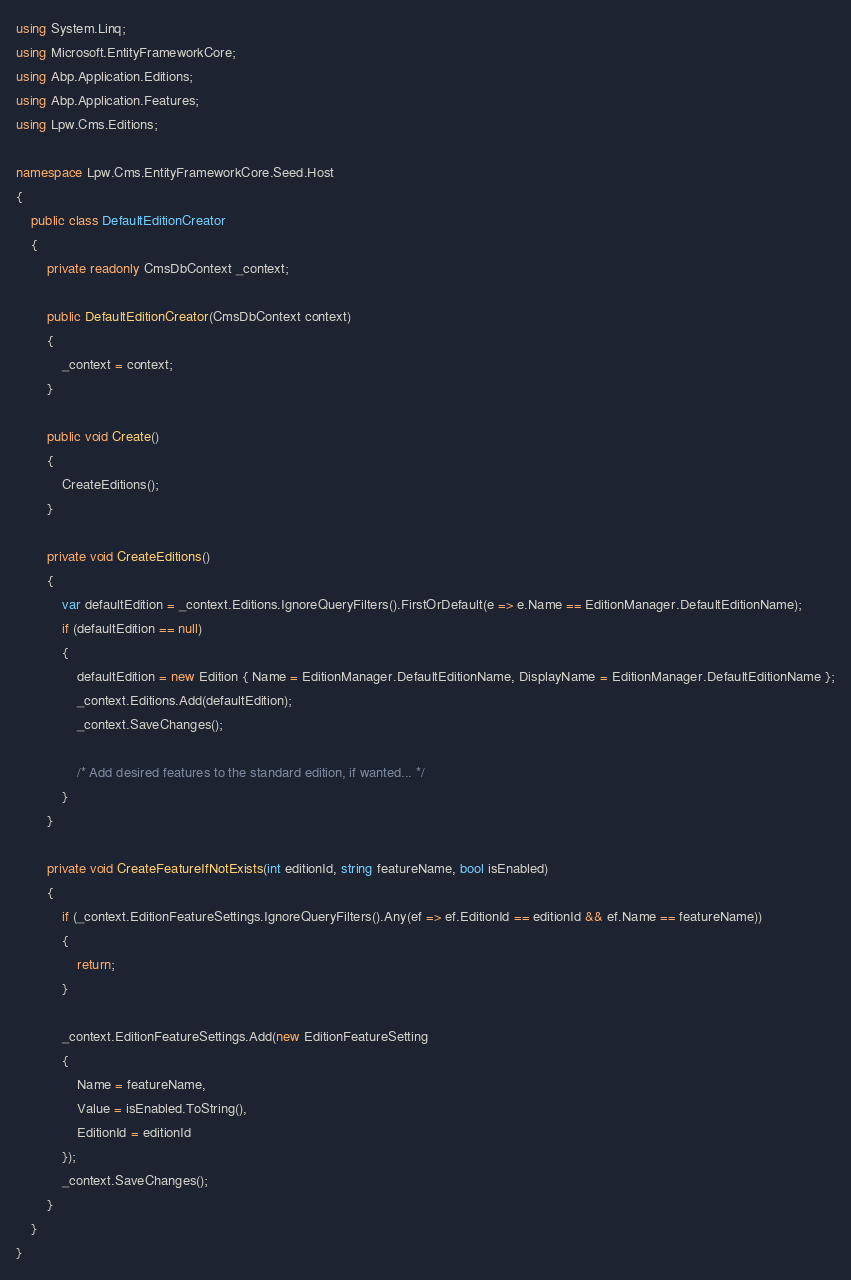Convert code to text. <code><loc_0><loc_0><loc_500><loc_500><_C#_>using System.Linq;
using Microsoft.EntityFrameworkCore;
using Abp.Application.Editions;
using Abp.Application.Features;
using Lpw.Cms.Editions;

namespace Lpw.Cms.EntityFrameworkCore.Seed.Host
{
    public class DefaultEditionCreator
    {
        private readonly CmsDbContext _context;

        public DefaultEditionCreator(CmsDbContext context)
        {
            _context = context;
        }

        public void Create()
        {
            CreateEditions();
        }

        private void CreateEditions()
        {
            var defaultEdition = _context.Editions.IgnoreQueryFilters().FirstOrDefault(e => e.Name == EditionManager.DefaultEditionName);
            if (defaultEdition == null)
            {
                defaultEdition = new Edition { Name = EditionManager.DefaultEditionName, DisplayName = EditionManager.DefaultEditionName };
                _context.Editions.Add(defaultEdition);
                _context.SaveChanges();

                /* Add desired features to the standard edition, if wanted... */
            }
        }

        private void CreateFeatureIfNotExists(int editionId, string featureName, bool isEnabled)
        {
            if (_context.EditionFeatureSettings.IgnoreQueryFilters().Any(ef => ef.EditionId == editionId && ef.Name == featureName))
            {
                return;
            }

            _context.EditionFeatureSettings.Add(new EditionFeatureSetting
            {
                Name = featureName,
                Value = isEnabled.ToString(),
                EditionId = editionId
            });
            _context.SaveChanges();
        }
    }
}
</code> 